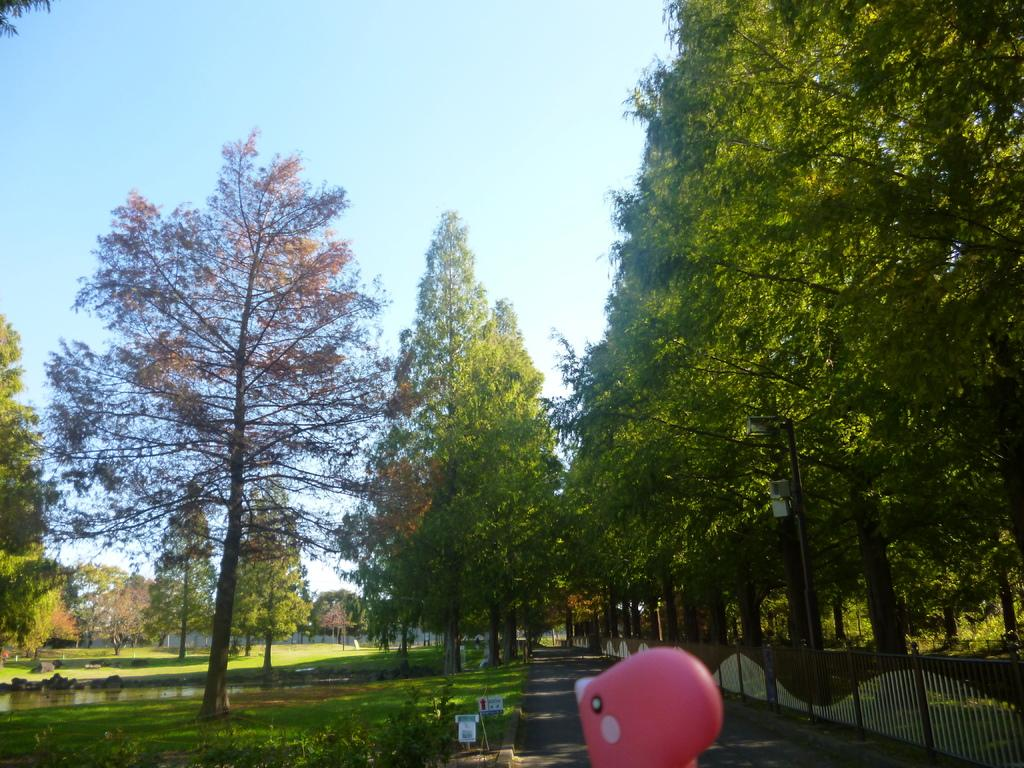What type of vegetation can be seen on the right side of the image? There are trees on the right side of the image. What structures are present on the right side of the image? There are poles and fencing on the right side of the image. What type of surface can be seen on the right side of the image? There are roads on the right side of the image. What type of vegetation can be seen on the left side of the image? There are trees on the left side of the image. What natural element is present on the left side of the image? There is water on the left side of the image. What type of ground cover is present on the left side of the image? There is grass on the left side of the image. What can be seen in the background of the image? There is sky visible in the background of the image. What type of wool is being sold at the airport in the image? There is no airport or wool present in the image. How does the profit from the trees on the right side of the image contribute to the local economy? There is no mention of profit or the local economy in the image, as it only shows trees, poles, fencing, and roads on the right side. 